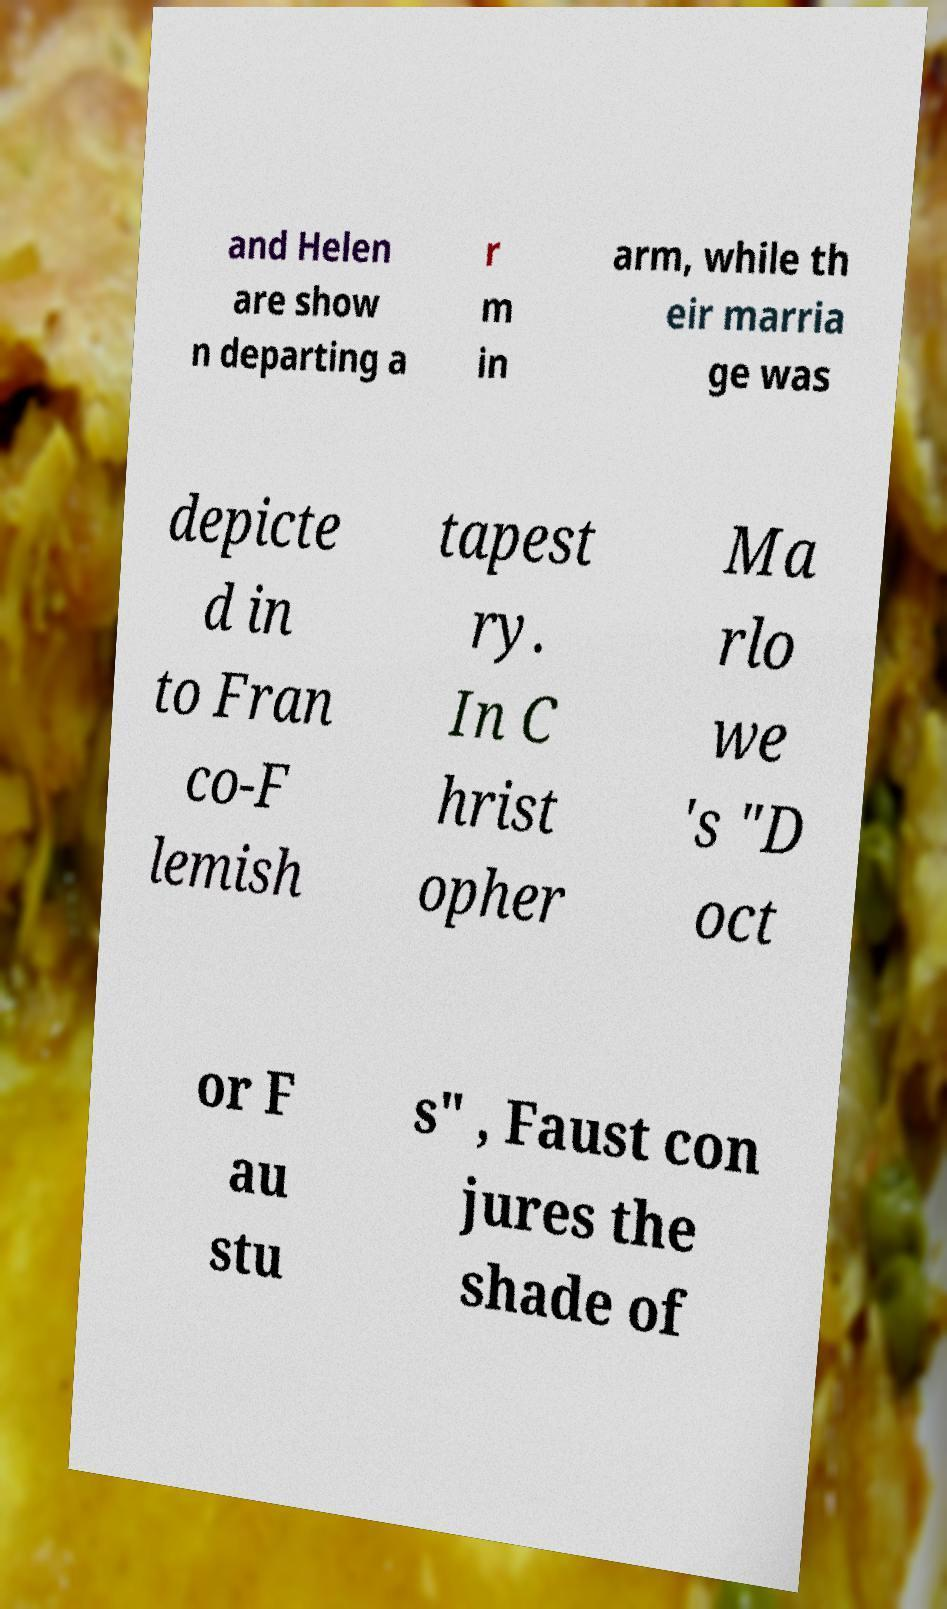Can you read and provide the text displayed in the image?This photo seems to have some interesting text. Can you extract and type it out for me? and Helen are show n departing a r m in arm, while th eir marria ge was depicte d in to Fran co-F lemish tapest ry. In C hrist opher Ma rlo we 's "D oct or F au stu s" , Faust con jures the shade of 